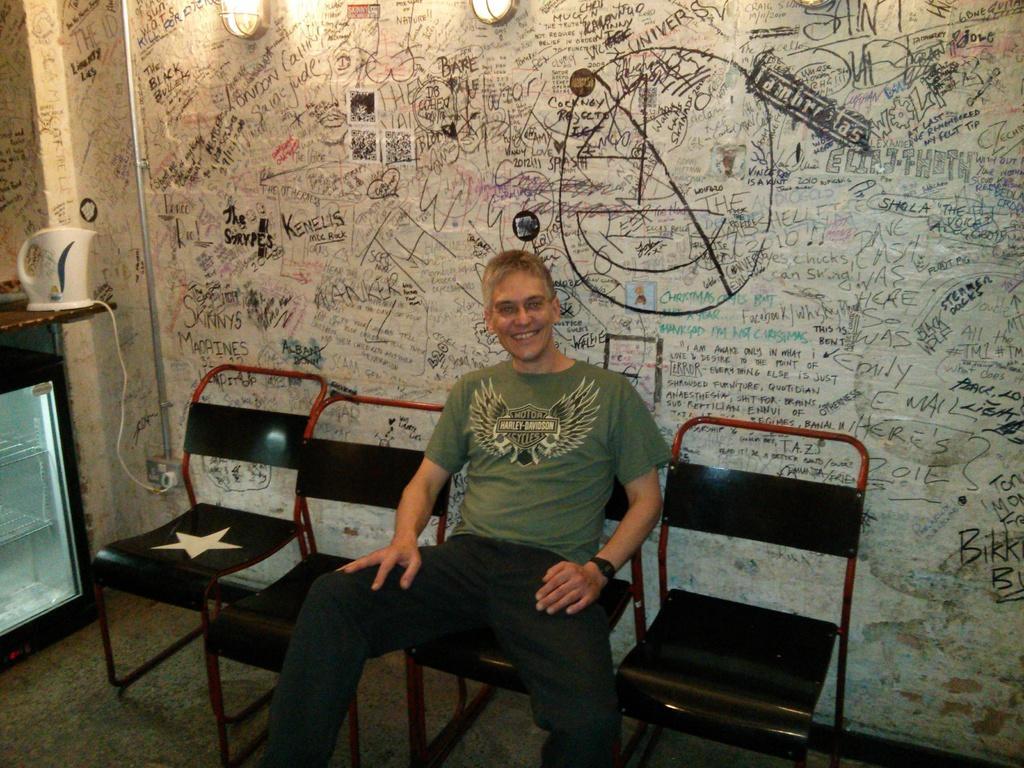Describe this image in one or two sentences. This picture shows a man sitting in the chair. There are four chairs here. In the background, there is a wall and some lights here. The man is smiling. 